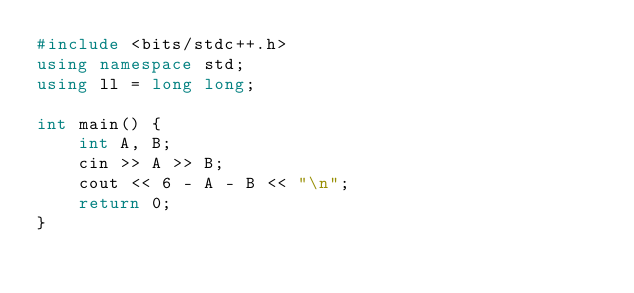Convert code to text. <code><loc_0><loc_0><loc_500><loc_500><_C++_>#include <bits/stdc++.h>
using namespace std;
using ll = long long;

int main() {
    int A, B;
    cin >> A >> B;
    cout << 6 - A - B << "\n";
    return 0;
}</code> 